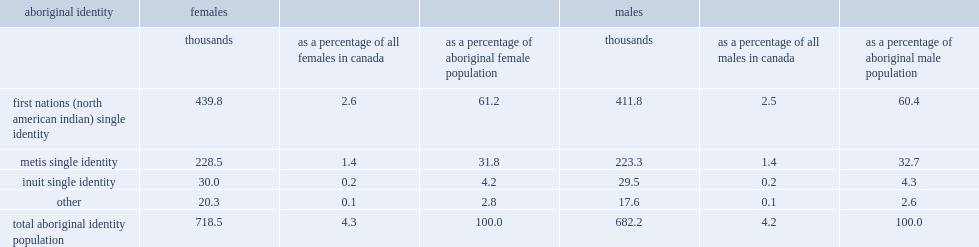How many women and girls reported an aboriginal identity? 718.5. What was the percentage of the total female population reported an aboriginal identity? 4.3. In 2011, what was the percentage of the aboriginal female population identified as first nations only? 61.2. In 2011, what was the percentage of the aboriginal female population identified as metis only? 31.8. In 2011, what was the percentage of the aboriginal female population identified as inuit only? 4.2. In 2011, what was the percentage of the aboriginal female population identified as other aboriginal identities or more than one aboriginal identity? 2.8. 